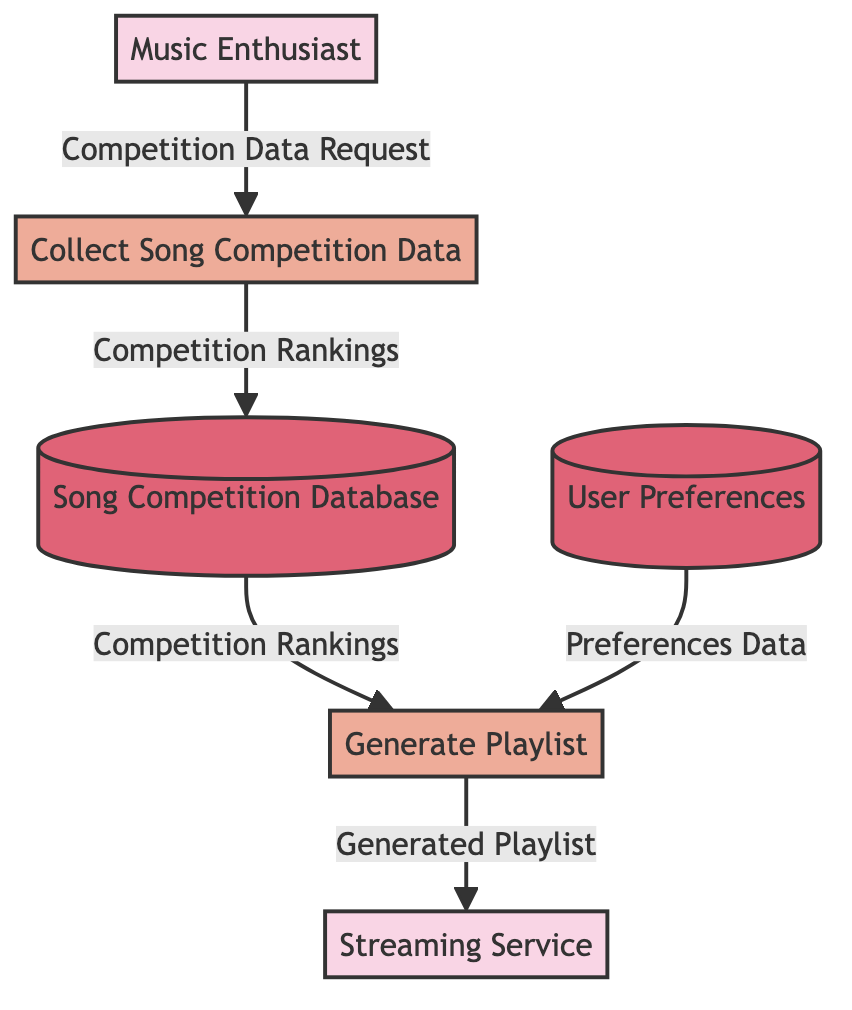What is the first process in the diagram? The first process is "Collect Song Competition Data," which is the initial step in the flow of playlist generation.
Answer: Collect Song Competition Data How many external entities are in the diagram? There are two external entities: "Music Enthusiast" and "Streaming Service."
Answer: 2 What data flows from the Song Competition Database to the Generate Playlist process? The data flowing from the Song Competition Database to the Generate Playlist process is called "Competition Rankings."
Answer: Competition Rankings Which data store contains user preferences? The data store containing user preferences is called "User Preferences." This store specifically holds data related to favorite genres, artists, and competition interests.
Answer: User Preferences What type of flow connects the Music Enthusiast to the Collect Song Competition Data process? The flow that connects the Music Enthusiast to the Collect Song Competition Data process is labeled as "Competition Data Request." This indicates that the Music Enthusiast initiates a request to collect data.
Answer: Competition Data Request What is the end result delivered to the Streaming Service? The end result delivered to the Streaming Service is called "Generated Playlist," which is created based on the rankings and user preferences.
Answer: Generated Playlist How does user preferences data enter the Generate Playlist process? User preferences data enters the Generate Playlist process labeled as "Preferences Data." This data influences how the playlist is generated based on individual user likes.
Answer: Preferences Data What is the relationship between the Song Competition Database and the Generate Playlist process? The relationship is that the Song Competition Database provides "Competition Rankings" data to the Generate Playlist process, which uses that information in playlist formation.
Answer: Competition Rankings What is the role of the Music Enthusiast in this diagram? The Music Enthusiast acts as the end user who interacts with the system to generate playlists based on song competition rankings.
Answer: End user 